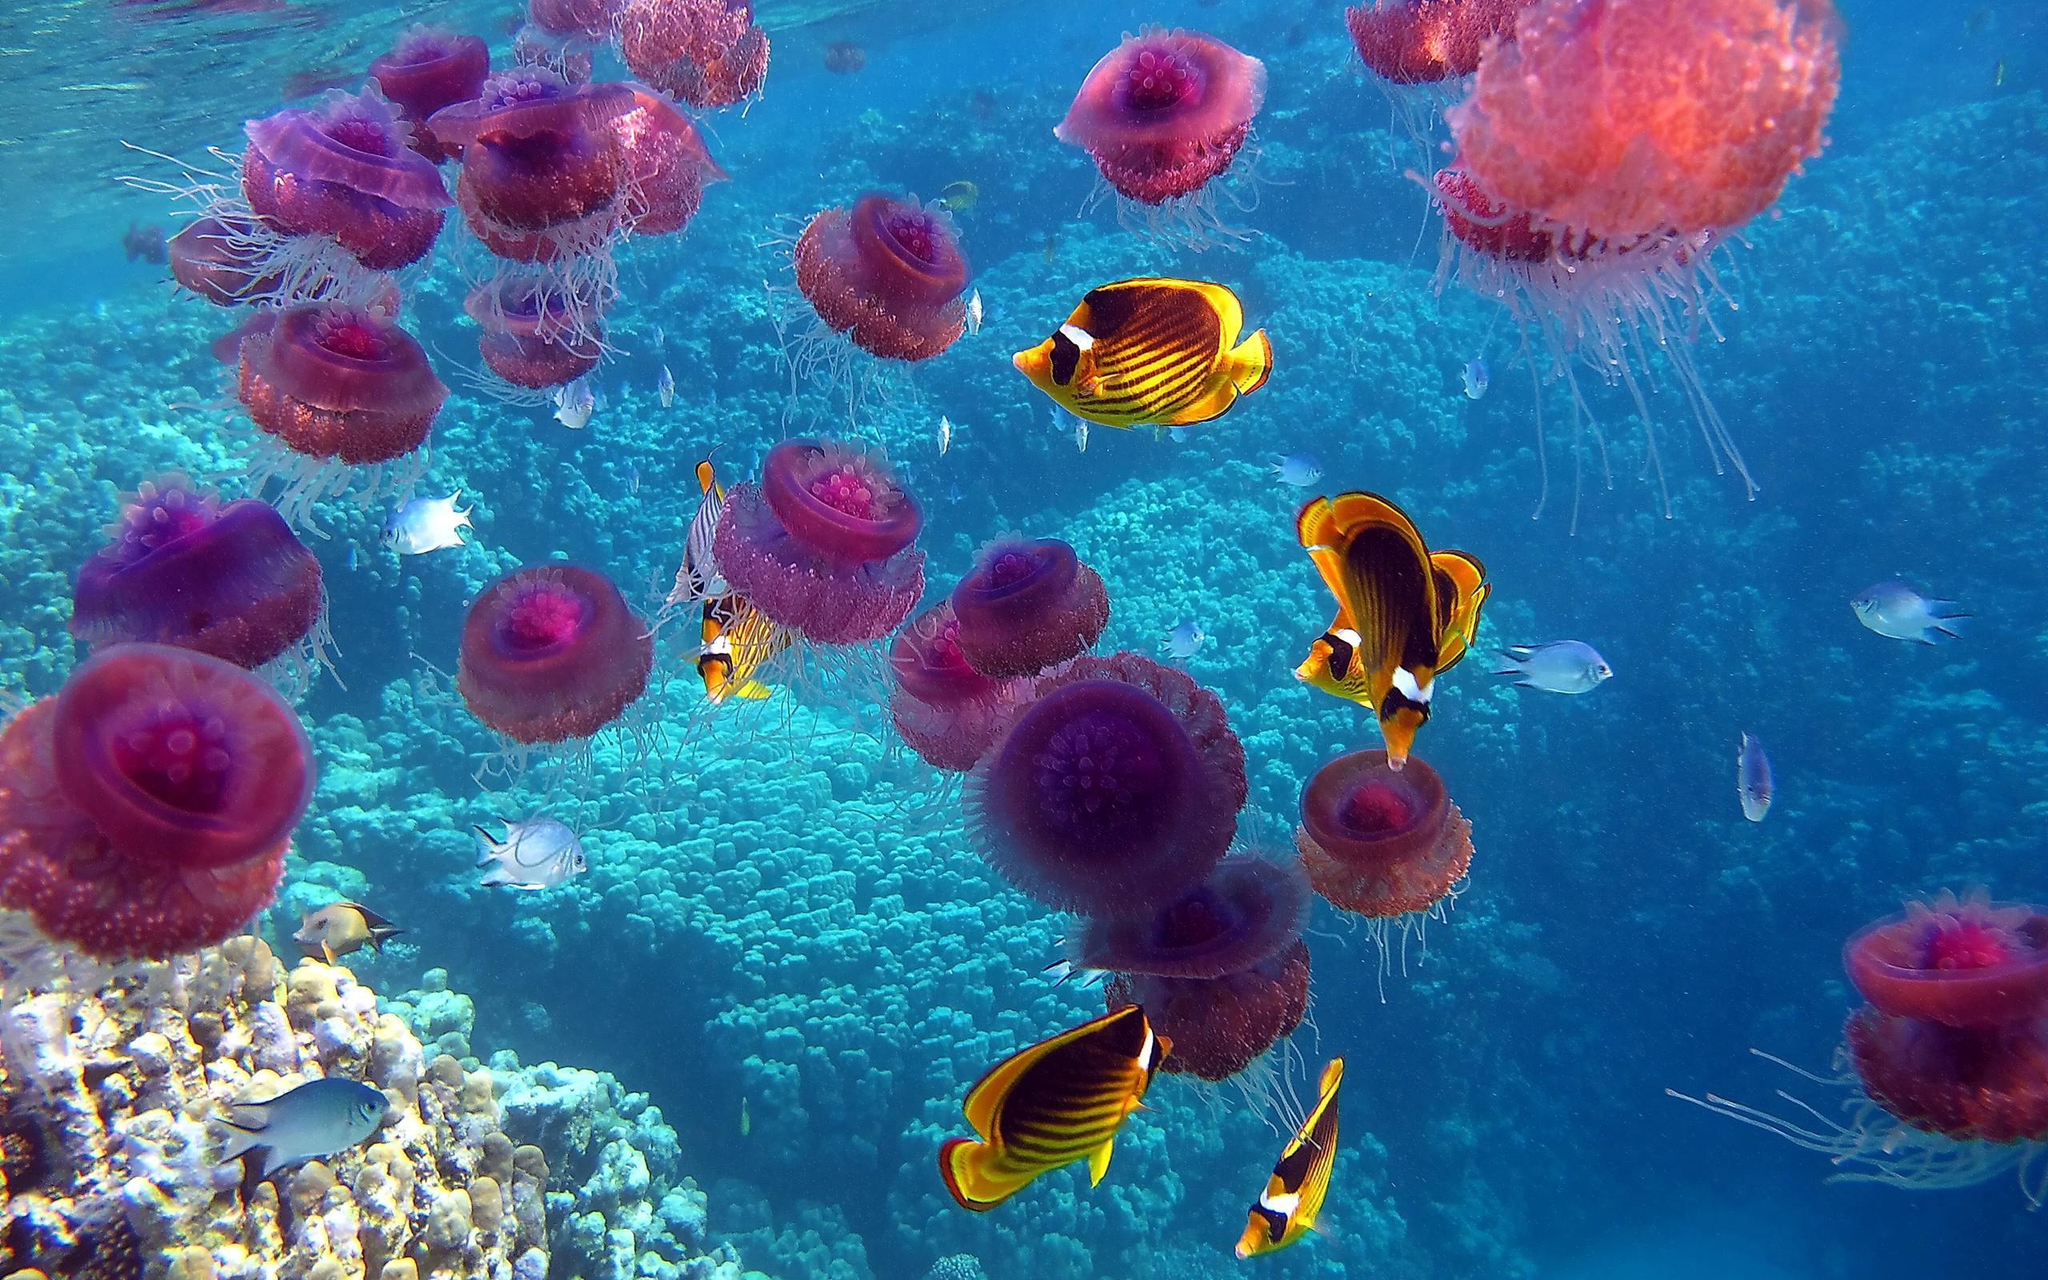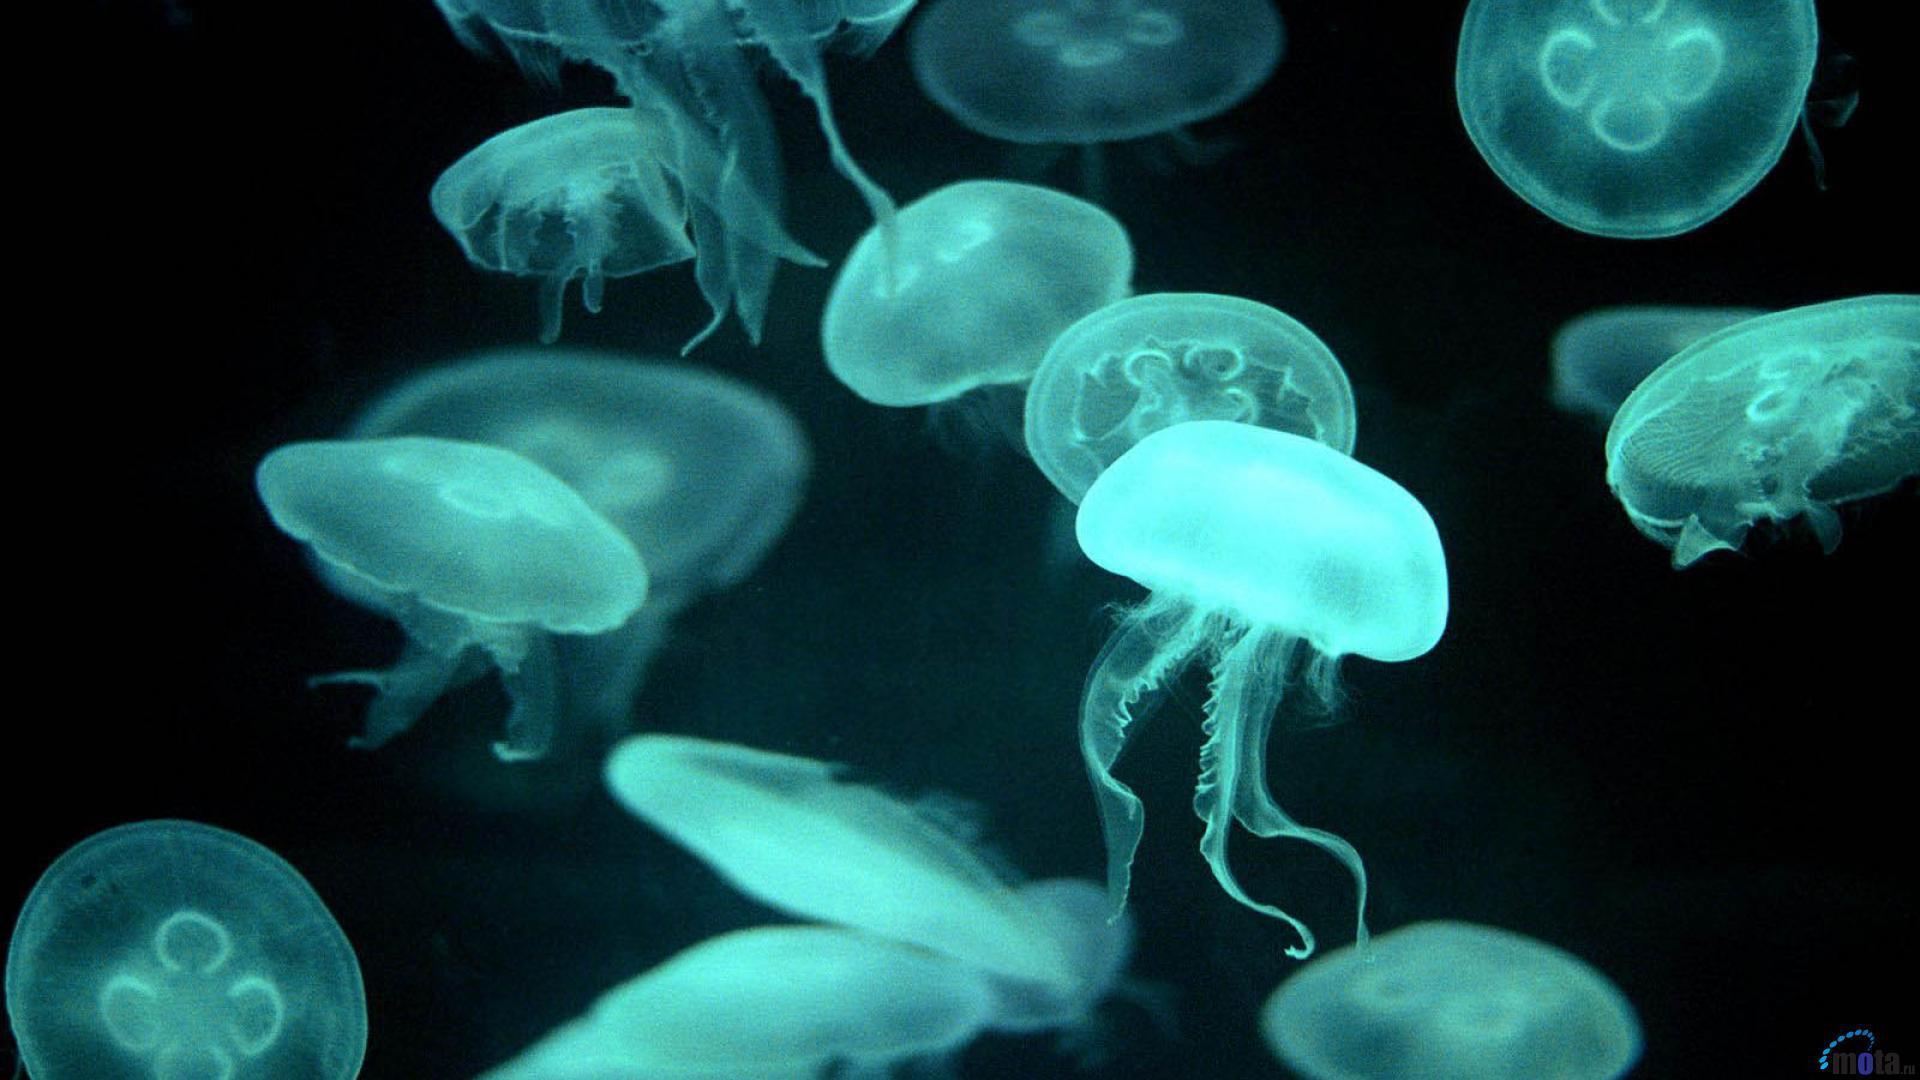The first image is the image on the left, the second image is the image on the right. Considering the images on both sides, is "There is at least one orange colored jellyfish." valid? Answer yes or no. No. The first image is the image on the left, the second image is the image on the right. Examine the images to the left and right. Is the description "All the jellyfish in one image are purplish-pink in color." accurate? Answer yes or no. Yes. 